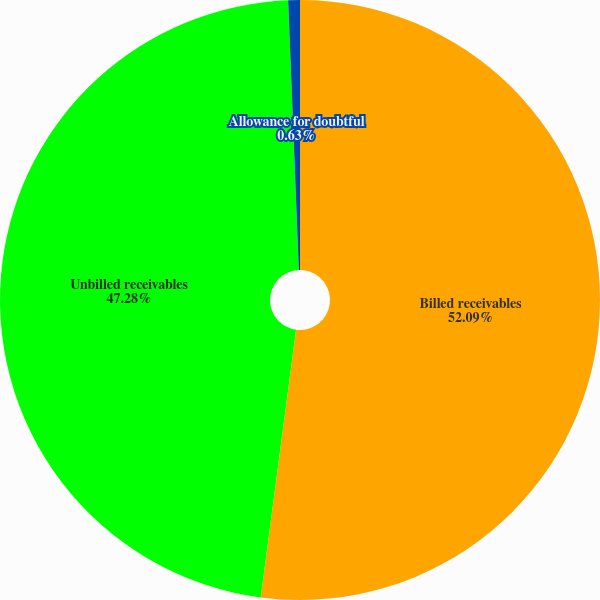Convert chart to OTSL. <chart><loc_0><loc_0><loc_500><loc_500><pie_chart><fcel>Billed receivables<fcel>Unbilled receivables<fcel>Allowance for doubtful<nl><fcel>52.09%<fcel>47.28%<fcel>0.63%<nl></chart> 